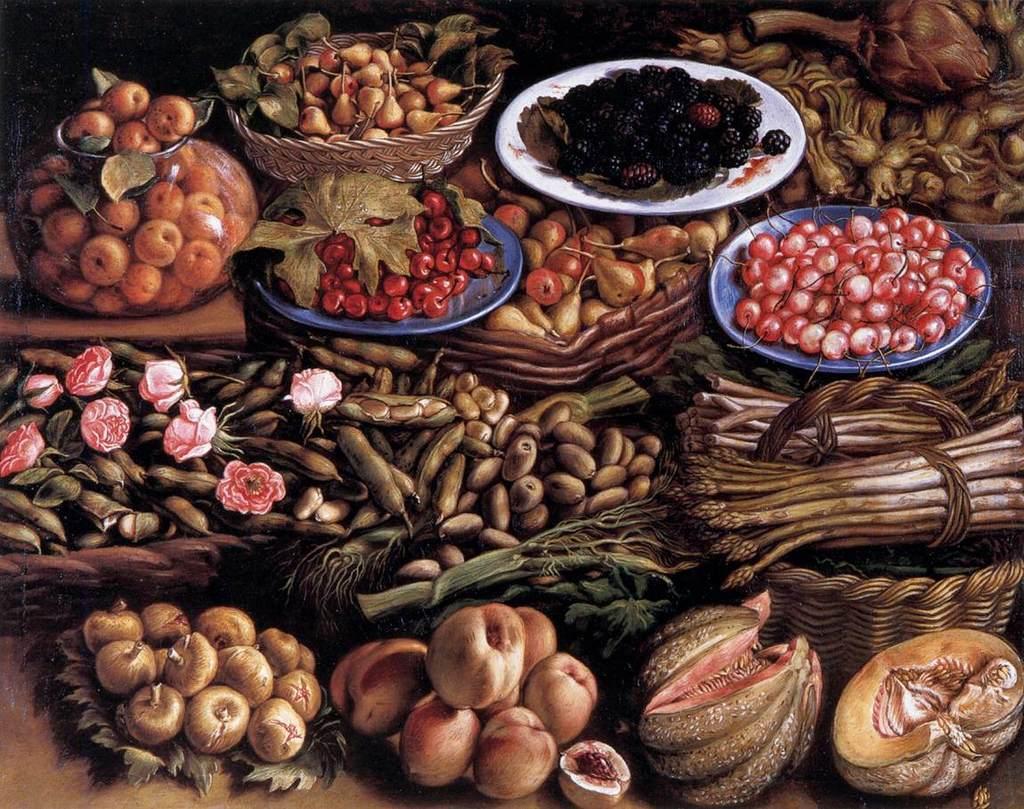Could you give a brief overview of what you see in this image? This is the picture of the painting. In this picture, we see fruits, vegetables and flowers. Here, we see the baskets containing vegetable and fruits, a bowl containing apples and plate containing fruits. 